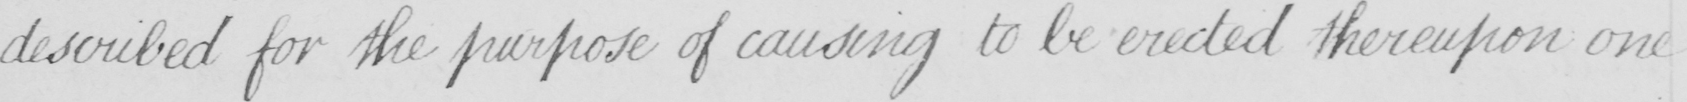Transcribe the text shown in this historical manuscript line. described for the purpose of causing to be erected thereupon one 